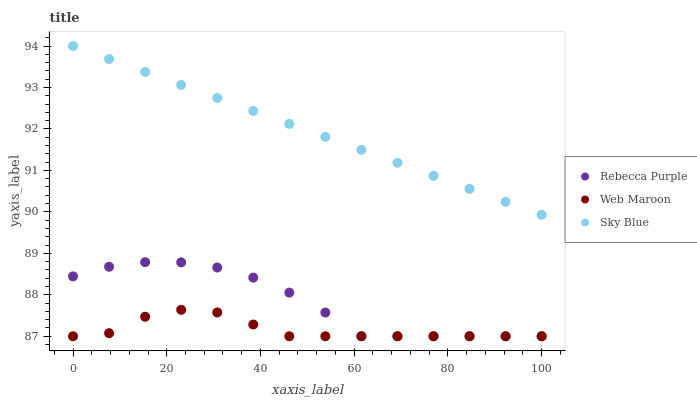Does Web Maroon have the minimum area under the curve?
Answer yes or no. Yes. Does Sky Blue have the maximum area under the curve?
Answer yes or no. Yes. Does Rebecca Purple have the minimum area under the curve?
Answer yes or no. No. Does Rebecca Purple have the maximum area under the curve?
Answer yes or no. No. Is Sky Blue the smoothest?
Answer yes or no. Yes. Is Rebecca Purple the roughest?
Answer yes or no. Yes. Is Web Maroon the smoothest?
Answer yes or no. No. Is Web Maroon the roughest?
Answer yes or no. No. Does Web Maroon have the lowest value?
Answer yes or no. Yes. Does Sky Blue have the highest value?
Answer yes or no. Yes. Does Rebecca Purple have the highest value?
Answer yes or no. No. Is Rebecca Purple less than Sky Blue?
Answer yes or no. Yes. Is Sky Blue greater than Web Maroon?
Answer yes or no. Yes. Does Web Maroon intersect Rebecca Purple?
Answer yes or no. Yes. Is Web Maroon less than Rebecca Purple?
Answer yes or no. No. Is Web Maroon greater than Rebecca Purple?
Answer yes or no. No. Does Rebecca Purple intersect Sky Blue?
Answer yes or no. No. 